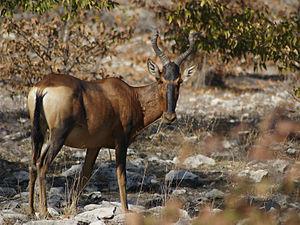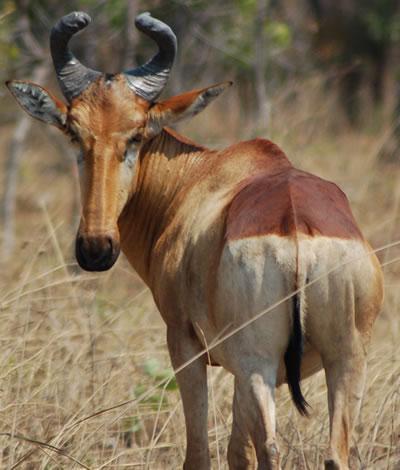The first image is the image on the left, the second image is the image on the right. For the images shown, is this caption "An image shows one horned animal with body in profile and face turned toward camera." true? Answer yes or no. Yes. 